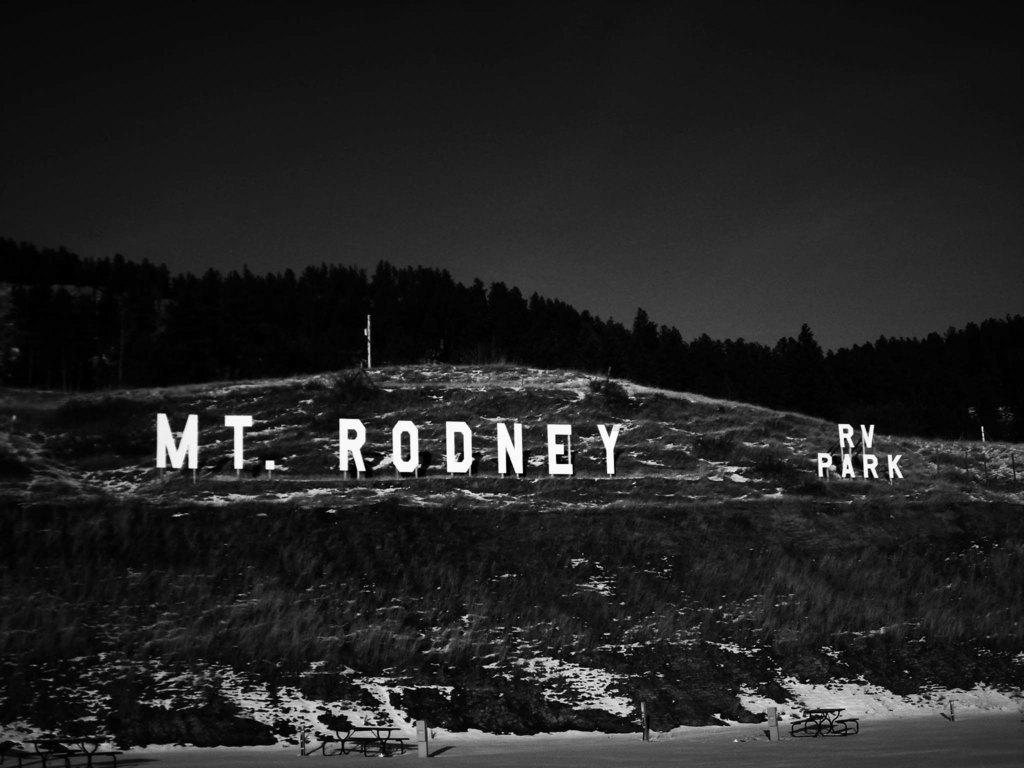<image>
Offer a succinct explanation of the picture presented. a black and white photo of the words 'mt. rodney rv park' on a mountain 